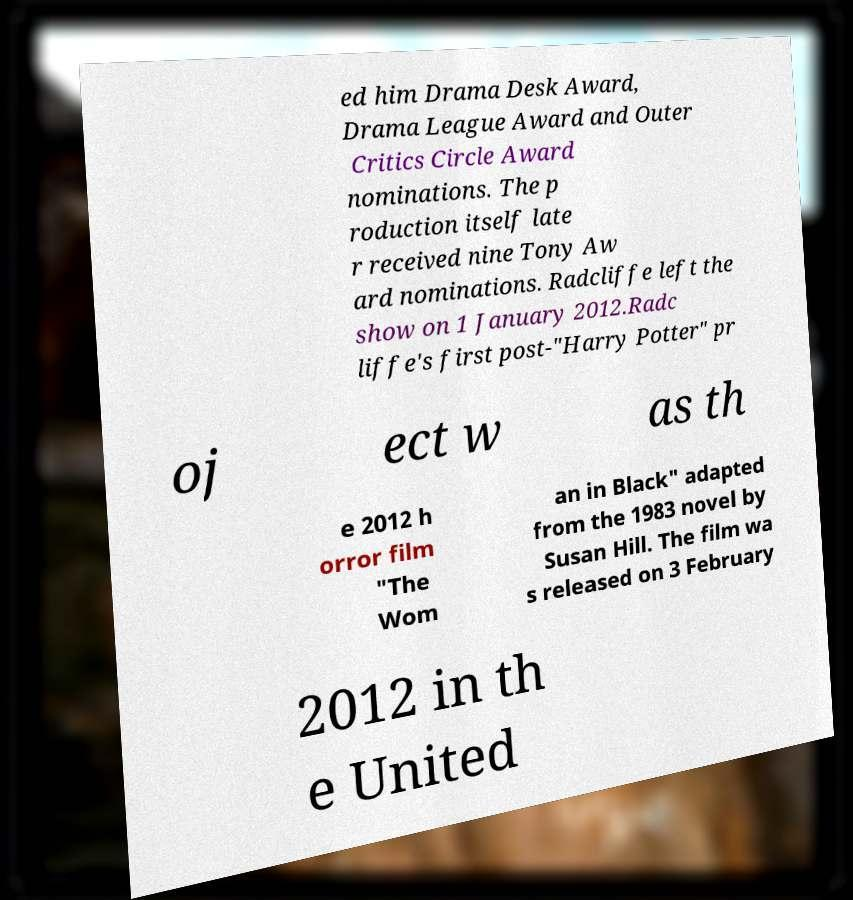Could you extract and type out the text from this image? ed him Drama Desk Award, Drama League Award and Outer Critics Circle Award nominations. The p roduction itself late r received nine Tony Aw ard nominations. Radcliffe left the show on 1 January 2012.Radc liffe's first post-"Harry Potter" pr oj ect w as th e 2012 h orror film "The Wom an in Black" adapted from the 1983 novel by Susan Hill. The film wa s released on 3 February 2012 in th e United 